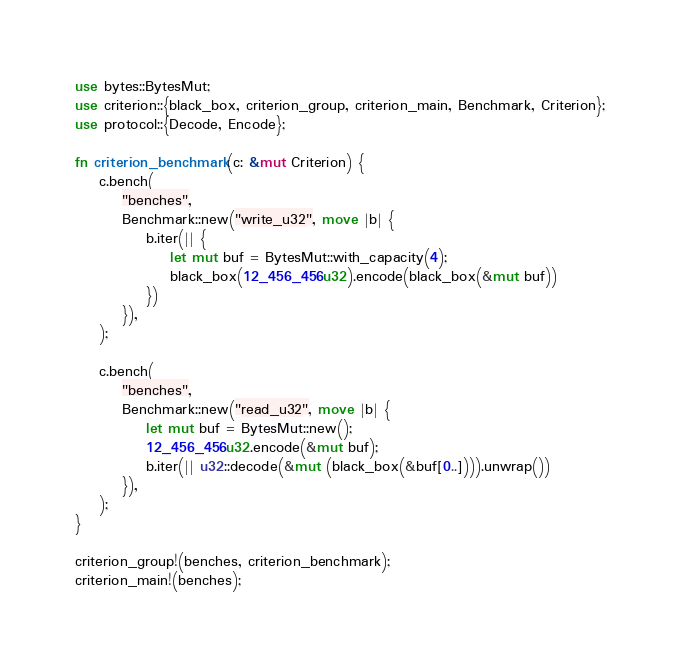<code> <loc_0><loc_0><loc_500><loc_500><_Rust_>use bytes::BytesMut;
use criterion::{black_box, criterion_group, criterion_main, Benchmark, Criterion};
use protocol::{Decode, Encode};

fn criterion_benchmark(c: &mut Criterion) {
    c.bench(
        "benches",
        Benchmark::new("write_u32", move |b| {
            b.iter(|| {
                let mut buf = BytesMut::with_capacity(4);
                black_box(12_456_456u32).encode(black_box(&mut buf))
            })
        }),
    );

    c.bench(
        "benches",
        Benchmark::new("read_u32", move |b| {
            let mut buf = BytesMut::new();
            12_456_456u32.encode(&mut buf);
            b.iter(|| u32::decode(&mut (black_box(&buf[0..]))).unwrap())
        }),
    );
}

criterion_group!(benches, criterion_benchmark);
criterion_main!(benches);
</code> 